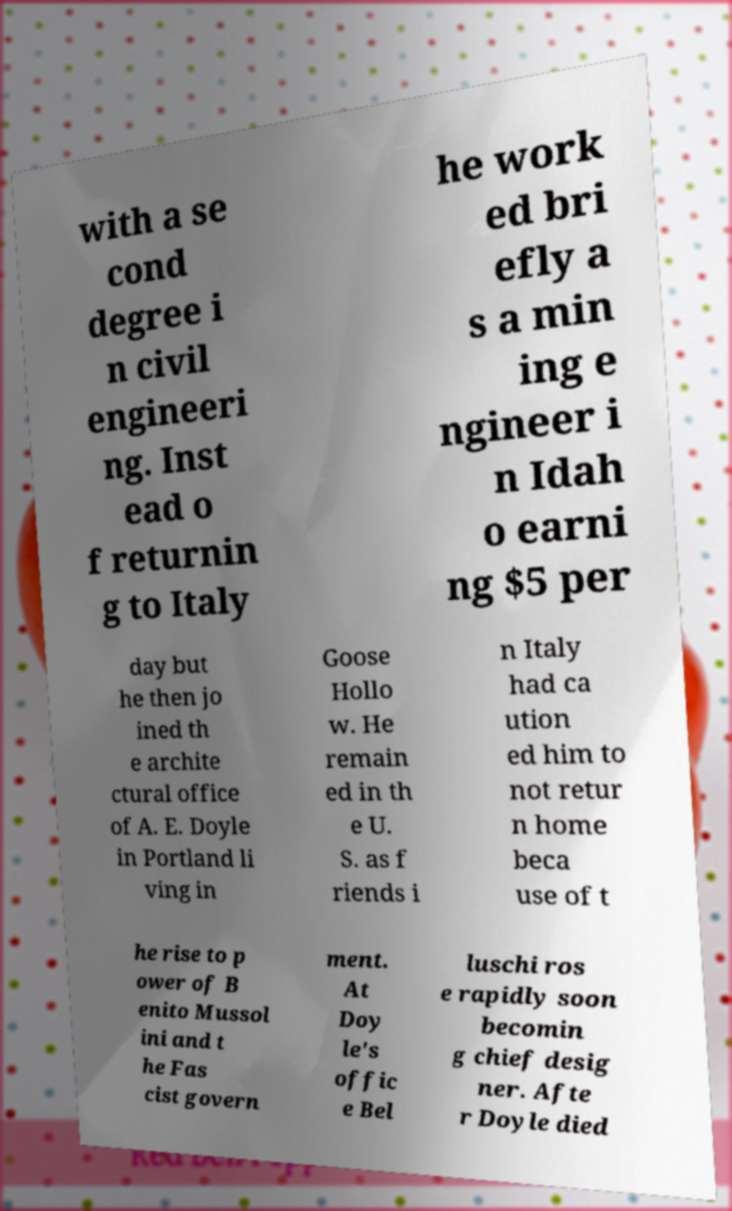Please identify and transcribe the text found in this image. with a se cond degree i n civil engineeri ng. Inst ead o f returnin g to Italy he work ed bri efly a s a min ing e ngineer i n Idah o earni ng $5 per day but he then jo ined th e archite ctural office of A. E. Doyle in Portland li ving in Goose Hollo w. He remain ed in th e U. S. as f riends i n Italy had ca ution ed him to not retur n home beca use of t he rise to p ower of B enito Mussol ini and t he Fas cist govern ment. At Doy le's offic e Bel luschi ros e rapidly soon becomin g chief desig ner. Afte r Doyle died 